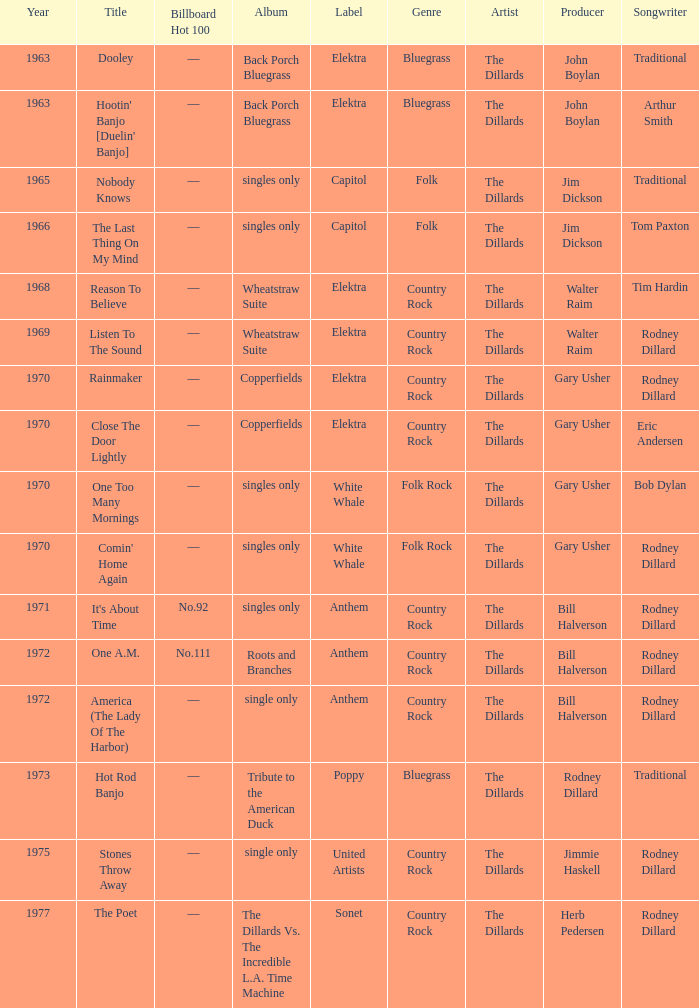What is the total years for roots and branches? 1972.0. 